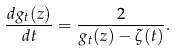<formula> <loc_0><loc_0><loc_500><loc_500>\frac { d g _ { t } ( z ) } { d t } = \frac { 2 } { g _ { t } ( z ) - \zeta ( t ) } .</formula> 